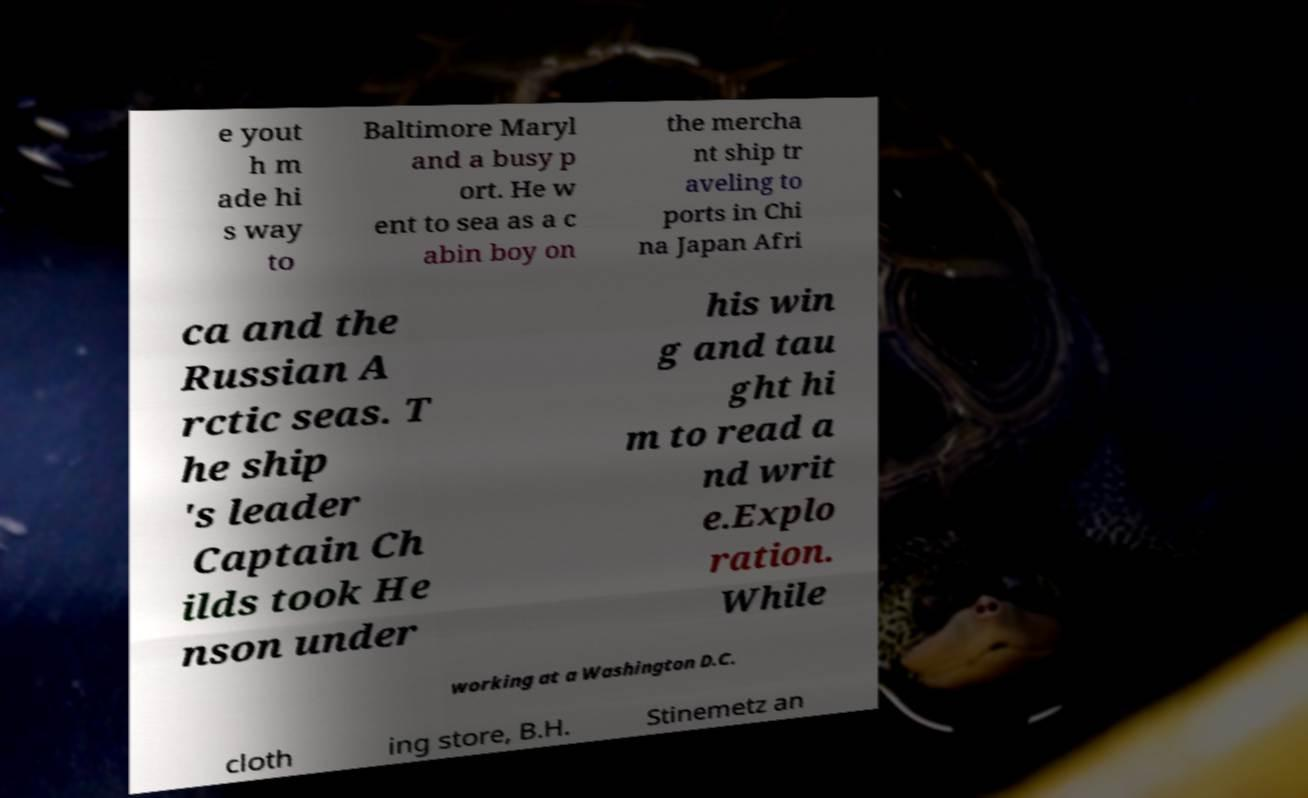For documentation purposes, I need the text within this image transcribed. Could you provide that? e yout h m ade hi s way to Baltimore Maryl and a busy p ort. He w ent to sea as a c abin boy on the mercha nt ship tr aveling to ports in Chi na Japan Afri ca and the Russian A rctic seas. T he ship 's leader Captain Ch ilds took He nson under his win g and tau ght hi m to read a nd writ e.Explo ration. While working at a Washington D.C. cloth ing store, B.H. Stinemetz an 